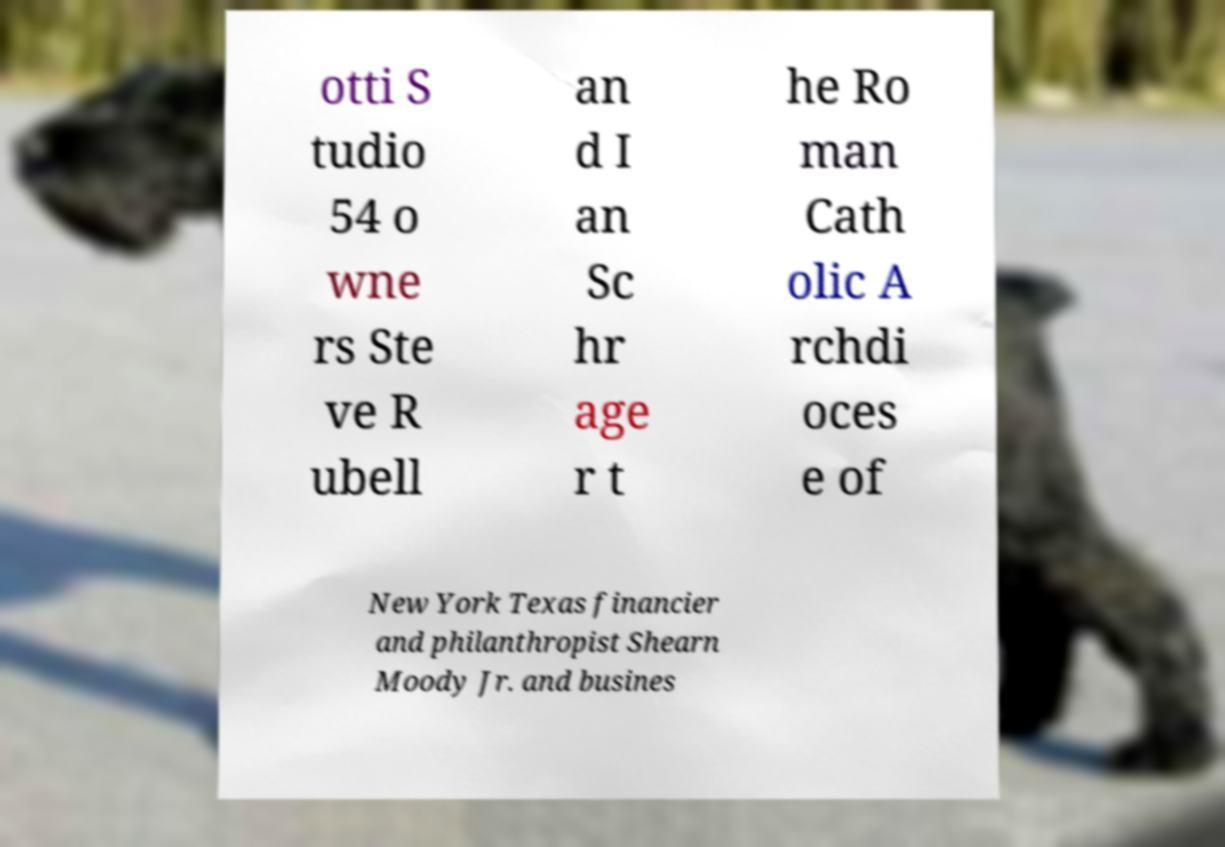Could you extract and type out the text from this image? otti S tudio 54 o wne rs Ste ve R ubell an d I an Sc hr age r t he Ro man Cath olic A rchdi oces e of New York Texas financier and philanthropist Shearn Moody Jr. and busines 